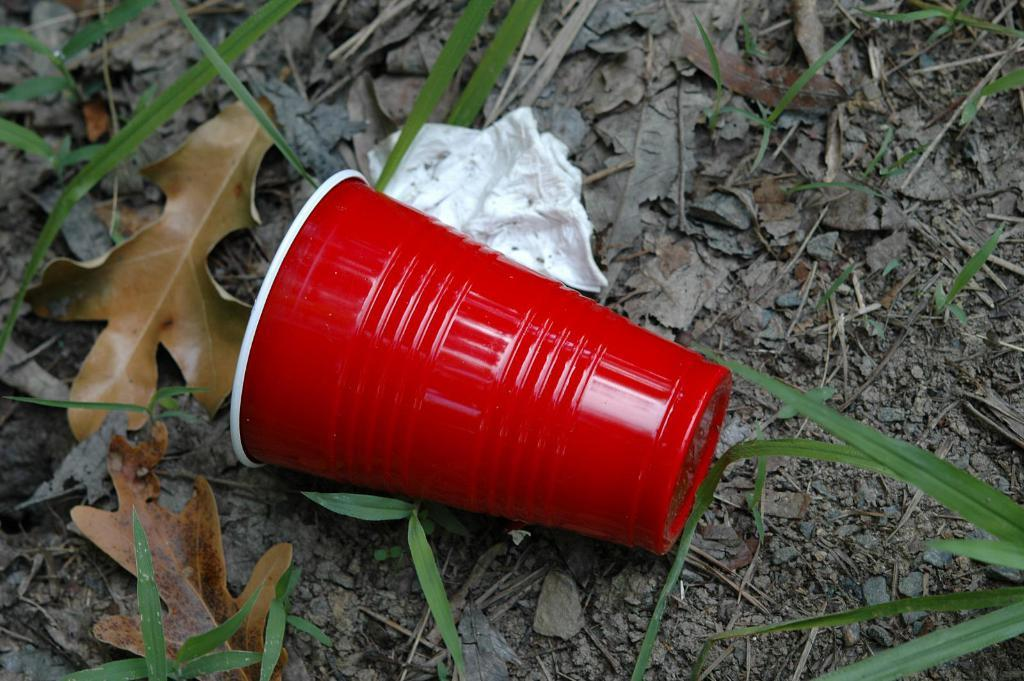What is the main object in the image? There is a glass in the image. What else can be seen in the image besides the glass? There is tissue paper in the image. What is located at the bottom of the image? There are leaves at the bottom of the image. What type of advertisement can be seen on the glass in the image? There is no advertisement present on the glass in the image. 